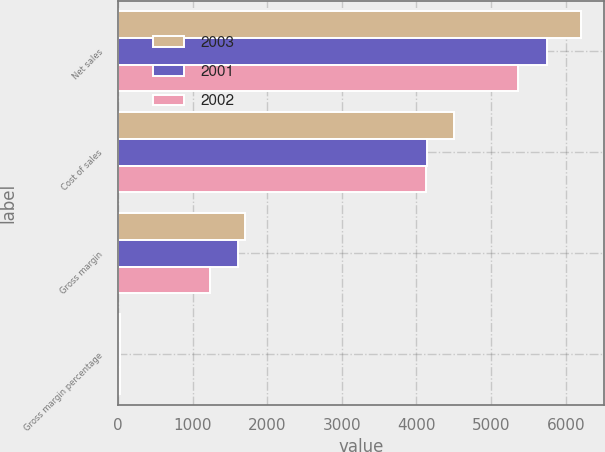<chart> <loc_0><loc_0><loc_500><loc_500><stacked_bar_chart><ecel><fcel>Net sales<fcel>Cost of sales<fcel>Gross margin<fcel>Gross margin percentage<nl><fcel>2003<fcel>6207<fcel>4499<fcel>1708<fcel>27.5<nl><fcel>2001<fcel>5742<fcel>4139<fcel>1603<fcel>27.9<nl><fcel>2002<fcel>5363<fcel>4128<fcel>1235<fcel>23<nl></chart> 